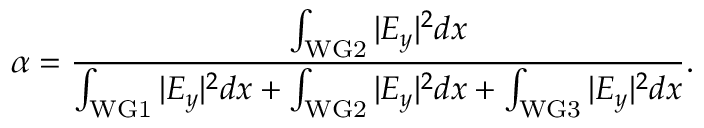Convert formula to latex. <formula><loc_0><loc_0><loc_500><loc_500>\alpha = \frac { \int _ { W G 2 } | E _ { y } | ^ { 2 } d x } { \int _ { W G 1 } | E _ { y } | ^ { 2 } d x + \int _ { W G 2 } | E _ { y } | ^ { 2 } d x + \int _ { W G 3 } | E _ { y } | ^ { 2 } d x } .</formula> 